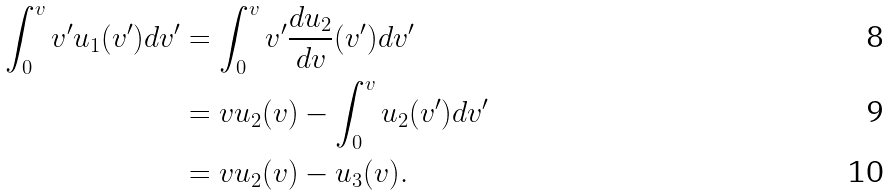Convert formula to latex. <formula><loc_0><loc_0><loc_500><loc_500>\int _ { 0 } ^ { v } v ^ { \prime } u _ { 1 } ( v ^ { \prime } ) d v ^ { \prime } & = \int _ { 0 } ^ { v } v ^ { \prime } \frac { d u _ { 2 } } { d v } ( v ^ { \prime } ) d v ^ { \prime } \\ & = v u _ { 2 } ( v ) - \int _ { 0 } ^ { v } u _ { 2 } ( v ^ { \prime } ) d v ^ { \prime } \\ & = v u _ { 2 } ( v ) - u _ { 3 } ( v ) .</formula> 